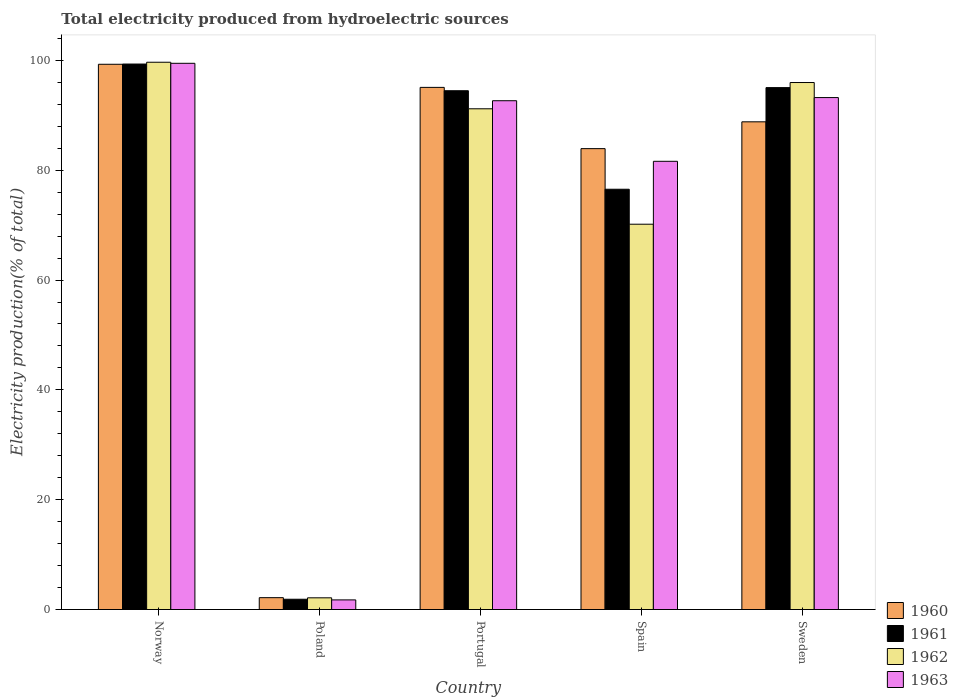How many groups of bars are there?
Give a very brief answer. 5. How many bars are there on the 2nd tick from the right?
Offer a terse response. 4. In how many cases, is the number of bars for a given country not equal to the number of legend labels?
Ensure brevity in your answer.  0. What is the total electricity produced in 1961 in Sweden?
Offer a very short reply. 95.05. Across all countries, what is the maximum total electricity produced in 1963?
Provide a succinct answer. 99.47. Across all countries, what is the minimum total electricity produced in 1961?
Offer a terse response. 1.87. In which country was the total electricity produced in 1961 maximum?
Give a very brief answer. Norway. In which country was the total electricity produced in 1963 minimum?
Your answer should be compact. Poland. What is the total total electricity produced in 1960 in the graph?
Offer a terse response. 369.31. What is the difference between the total electricity produced in 1960 in Norway and that in Poland?
Provide a short and direct response. 97.14. What is the difference between the total electricity produced in 1963 in Portugal and the total electricity produced in 1961 in Spain?
Give a very brief answer. 16.12. What is the average total electricity produced in 1961 per country?
Provide a succinct answer. 73.46. What is the difference between the total electricity produced of/in 1962 and total electricity produced of/in 1961 in Poland?
Offer a terse response. 0.26. In how many countries, is the total electricity produced in 1960 greater than 28 %?
Offer a very short reply. 4. What is the ratio of the total electricity produced in 1963 in Norway to that in Spain?
Offer a very short reply. 1.22. Is the total electricity produced in 1960 in Norway less than that in Spain?
Your answer should be very brief. No. What is the difference between the highest and the second highest total electricity produced in 1960?
Ensure brevity in your answer.  -10.48. What is the difference between the highest and the lowest total electricity produced in 1961?
Your response must be concise. 97.47. Is it the case that in every country, the sum of the total electricity produced in 1962 and total electricity produced in 1961 is greater than the sum of total electricity produced in 1960 and total electricity produced in 1963?
Your response must be concise. No. What does the 2nd bar from the left in Poland represents?
Offer a terse response. 1961. Are all the bars in the graph horizontal?
Your answer should be very brief. No. How many countries are there in the graph?
Ensure brevity in your answer.  5. Are the values on the major ticks of Y-axis written in scientific E-notation?
Your answer should be compact. No. Does the graph contain any zero values?
Your answer should be compact. No. What is the title of the graph?
Your answer should be compact. Total electricity produced from hydroelectric sources. What is the Electricity production(% of total) of 1960 in Norway?
Your response must be concise. 99.3. What is the Electricity production(% of total) in 1961 in Norway?
Offer a very short reply. 99.34. What is the Electricity production(% of total) in 1962 in Norway?
Ensure brevity in your answer.  99.67. What is the Electricity production(% of total) of 1963 in Norway?
Your answer should be very brief. 99.47. What is the Electricity production(% of total) of 1960 in Poland?
Keep it short and to the point. 2.16. What is the Electricity production(% of total) in 1961 in Poland?
Provide a succinct answer. 1.87. What is the Electricity production(% of total) of 1962 in Poland?
Your response must be concise. 2.13. What is the Electricity production(% of total) in 1963 in Poland?
Ensure brevity in your answer.  1.75. What is the Electricity production(% of total) of 1960 in Portugal?
Give a very brief answer. 95.09. What is the Electricity production(% of total) in 1961 in Portugal?
Keep it short and to the point. 94.48. What is the Electricity production(% of total) of 1962 in Portugal?
Provide a short and direct response. 91.19. What is the Electricity production(% of total) in 1963 in Portugal?
Provide a succinct answer. 92.66. What is the Electricity production(% of total) in 1960 in Spain?
Provide a short and direct response. 83.94. What is the Electricity production(% of total) in 1961 in Spain?
Give a very brief answer. 76.54. What is the Electricity production(% of total) of 1962 in Spain?
Offer a terse response. 70.17. What is the Electricity production(% of total) in 1963 in Spain?
Offer a very short reply. 81.63. What is the Electricity production(% of total) of 1960 in Sweden?
Provide a succinct answer. 88.82. What is the Electricity production(% of total) in 1961 in Sweden?
Provide a short and direct response. 95.05. What is the Electricity production(% of total) of 1962 in Sweden?
Offer a terse response. 95.98. What is the Electricity production(% of total) of 1963 in Sweden?
Make the answer very short. 93.24. Across all countries, what is the maximum Electricity production(% of total) of 1960?
Give a very brief answer. 99.3. Across all countries, what is the maximum Electricity production(% of total) of 1961?
Give a very brief answer. 99.34. Across all countries, what is the maximum Electricity production(% of total) of 1962?
Make the answer very short. 99.67. Across all countries, what is the maximum Electricity production(% of total) in 1963?
Offer a very short reply. 99.47. Across all countries, what is the minimum Electricity production(% of total) in 1960?
Provide a succinct answer. 2.16. Across all countries, what is the minimum Electricity production(% of total) of 1961?
Provide a short and direct response. 1.87. Across all countries, what is the minimum Electricity production(% of total) in 1962?
Keep it short and to the point. 2.13. Across all countries, what is the minimum Electricity production(% of total) of 1963?
Your response must be concise. 1.75. What is the total Electricity production(% of total) in 1960 in the graph?
Keep it short and to the point. 369.31. What is the total Electricity production(% of total) of 1961 in the graph?
Provide a short and direct response. 367.29. What is the total Electricity production(% of total) in 1962 in the graph?
Give a very brief answer. 359.14. What is the total Electricity production(% of total) in 1963 in the graph?
Provide a short and direct response. 368.75. What is the difference between the Electricity production(% of total) of 1960 in Norway and that in Poland?
Ensure brevity in your answer.  97.14. What is the difference between the Electricity production(% of total) of 1961 in Norway and that in Poland?
Offer a very short reply. 97.47. What is the difference between the Electricity production(% of total) of 1962 in Norway and that in Poland?
Your answer should be compact. 97.54. What is the difference between the Electricity production(% of total) in 1963 in Norway and that in Poland?
Your answer should be compact. 97.72. What is the difference between the Electricity production(% of total) of 1960 in Norway and that in Portugal?
Provide a short and direct response. 4.21. What is the difference between the Electricity production(% of total) of 1961 in Norway and that in Portugal?
Offer a terse response. 4.86. What is the difference between the Electricity production(% of total) of 1962 in Norway and that in Portugal?
Your response must be concise. 8.48. What is the difference between the Electricity production(% of total) in 1963 in Norway and that in Portugal?
Your response must be concise. 6.81. What is the difference between the Electricity production(% of total) of 1960 in Norway and that in Spain?
Your answer should be very brief. 15.36. What is the difference between the Electricity production(% of total) of 1961 in Norway and that in Spain?
Provide a succinct answer. 22.8. What is the difference between the Electricity production(% of total) of 1962 in Norway and that in Spain?
Give a very brief answer. 29.5. What is the difference between the Electricity production(% of total) in 1963 in Norway and that in Spain?
Keep it short and to the point. 17.85. What is the difference between the Electricity production(% of total) of 1960 in Norway and that in Sweden?
Offer a very short reply. 10.48. What is the difference between the Electricity production(% of total) of 1961 in Norway and that in Sweden?
Your response must be concise. 4.29. What is the difference between the Electricity production(% of total) of 1962 in Norway and that in Sweden?
Your answer should be compact. 3.69. What is the difference between the Electricity production(% of total) in 1963 in Norway and that in Sweden?
Your response must be concise. 6.24. What is the difference between the Electricity production(% of total) in 1960 in Poland and that in Portugal?
Your answer should be compact. -92.93. What is the difference between the Electricity production(% of total) of 1961 in Poland and that in Portugal?
Provide a succinct answer. -92.61. What is the difference between the Electricity production(% of total) of 1962 in Poland and that in Portugal?
Ensure brevity in your answer.  -89.06. What is the difference between the Electricity production(% of total) in 1963 in Poland and that in Portugal?
Your response must be concise. -90.91. What is the difference between the Electricity production(% of total) of 1960 in Poland and that in Spain?
Provide a short and direct response. -81.78. What is the difference between the Electricity production(% of total) in 1961 in Poland and that in Spain?
Keep it short and to the point. -74.67. What is the difference between the Electricity production(% of total) of 1962 in Poland and that in Spain?
Your answer should be compact. -68.04. What is the difference between the Electricity production(% of total) in 1963 in Poland and that in Spain?
Keep it short and to the point. -79.88. What is the difference between the Electricity production(% of total) in 1960 in Poland and that in Sweden?
Offer a very short reply. -86.66. What is the difference between the Electricity production(% of total) of 1961 in Poland and that in Sweden?
Provide a short and direct response. -93.17. What is the difference between the Electricity production(% of total) in 1962 in Poland and that in Sweden?
Your answer should be compact. -93.84. What is the difference between the Electricity production(% of total) of 1963 in Poland and that in Sweden?
Provide a succinct answer. -91.48. What is the difference between the Electricity production(% of total) of 1960 in Portugal and that in Spain?
Offer a terse response. 11.15. What is the difference between the Electricity production(% of total) in 1961 in Portugal and that in Spain?
Your answer should be compact. 17.94. What is the difference between the Electricity production(% of total) in 1962 in Portugal and that in Spain?
Your response must be concise. 21.02. What is the difference between the Electricity production(% of total) in 1963 in Portugal and that in Spain?
Your answer should be very brief. 11.03. What is the difference between the Electricity production(% of total) of 1960 in Portugal and that in Sweden?
Make the answer very short. 6.27. What is the difference between the Electricity production(% of total) in 1961 in Portugal and that in Sweden?
Ensure brevity in your answer.  -0.57. What is the difference between the Electricity production(% of total) in 1962 in Portugal and that in Sweden?
Provide a short and direct response. -4.78. What is the difference between the Electricity production(% of total) in 1963 in Portugal and that in Sweden?
Your answer should be very brief. -0.58. What is the difference between the Electricity production(% of total) of 1960 in Spain and that in Sweden?
Your answer should be compact. -4.88. What is the difference between the Electricity production(% of total) in 1961 in Spain and that in Sweden?
Ensure brevity in your answer.  -18.51. What is the difference between the Electricity production(% of total) of 1962 in Spain and that in Sweden?
Provide a short and direct response. -25.8. What is the difference between the Electricity production(% of total) of 1963 in Spain and that in Sweden?
Give a very brief answer. -11.61. What is the difference between the Electricity production(% of total) in 1960 in Norway and the Electricity production(% of total) in 1961 in Poland?
Keep it short and to the point. 97.43. What is the difference between the Electricity production(% of total) of 1960 in Norway and the Electricity production(% of total) of 1962 in Poland?
Your answer should be compact. 97.17. What is the difference between the Electricity production(% of total) of 1960 in Norway and the Electricity production(% of total) of 1963 in Poland?
Your response must be concise. 97.55. What is the difference between the Electricity production(% of total) of 1961 in Norway and the Electricity production(% of total) of 1962 in Poland?
Provide a succinct answer. 97.21. What is the difference between the Electricity production(% of total) of 1961 in Norway and the Electricity production(% of total) of 1963 in Poland?
Ensure brevity in your answer.  97.59. What is the difference between the Electricity production(% of total) of 1962 in Norway and the Electricity production(% of total) of 1963 in Poland?
Ensure brevity in your answer.  97.92. What is the difference between the Electricity production(% of total) in 1960 in Norway and the Electricity production(% of total) in 1961 in Portugal?
Give a very brief answer. 4.82. What is the difference between the Electricity production(% of total) of 1960 in Norway and the Electricity production(% of total) of 1962 in Portugal?
Your response must be concise. 8.11. What is the difference between the Electricity production(% of total) of 1960 in Norway and the Electricity production(% of total) of 1963 in Portugal?
Your answer should be very brief. 6.64. What is the difference between the Electricity production(% of total) of 1961 in Norway and the Electricity production(% of total) of 1962 in Portugal?
Keep it short and to the point. 8.15. What is the difference between the Electricity production(% of total) in 1961 in Norway and the Electricity production(% of total) in 1963 in Portugal?
Keep it short and to the point. 6.68. What is the difference between the Electricity production(% of total) of 1962 in Norway and the Electricity production(% of total) of 1963 in Portugal?
Keep it short and to the point. 7.01. What is the difference between the Electricity production(% of total) in 1960 in Norway and the Electricity production(% of total) in 1961 in Spain?
Your response must be concise. 22.76. What is the difference between the Electricity production(% of total) of 1960 in Norway and the Electricity production(% of total) of 1962 in Spain?
Give a very brief answer. 29.13. What is the difference between the Electricity production(% of total) of 1960 in Norway and the Electricity production(% of total) of 1963 in Spain?
Offer a very short reply. 17.67. What is the difference between the Electricity production(% of total) of 1961 in Norway and the Electricity production(% of total) of 1962 in Spain?
Keep it short and to the point. 29.17. What is the difference between the Electricity production(% of total) in 1961 in Norway and the Electricity production(% of total) in 1963 in Spain?
Your answer should be very brief. 17.72. What is the difference between the Electricity production(% of total) of 1962 in Norway and the Electricity production(% of total) of 1963 in Spain?
Your answer should be compact. 18.04. What is the difference between the Electricity production(% of total) in 1960 in Norway and the Electricity production(% of total) in 1961 in Sweden?
Your response must be concise. 4.25. What is the difference between the Electricity production(% of total) in 1960 in Norway and the Electricity production(% of total) in 1962 in Sweden?
Offer a very short reply. 3.33. What is the difference between the Electricity production(% of total) of 1960 in Norway and the Electricity production(% of total) of 1963 in Sweden?
Ensure brevity in your answer.  6.06. What is the difference between the Electricity production(% of total) of 1961 in Norway and the Electricity production(% of total) of 1962 in Sweden?
Keep it short and to the point. 3.37. What is the difference between the Electricity production(% of total) in 1961 in Norway and the Electricity production(% of total) in 1963 in Sweden?
Ensure brevity in your answer.  6.11. What is the difference between the Electricity production(% of total) in 1962 in Norway and the Electricity production(% of total) in 1963 in Sweden?
Offer a terse response. 6.43. What is the difference between the Electricity production(% of total) of 1960 in Poland and the Electricity production(% of total) of 1961 in Portugal?
Your answer should be very brief. -92.32. What is the difference between the Electricity production(% of total) in 1960 in Poland and the Electricity production(% of total) in 1962 in Portugal?
Provide a succinct answer. -89.03. What is the difference between the Electricity production(% of total) in 1960 in Poland and the Electricity production(% of total) in 1963 in Portugal?
Keep it short and to the point. -90.5. What is the difference between the Electricity production(% of total) in 1961 in Poland and the Electricity production(% of total) in 1962 in Portugal?
Offer a terse response. -89.32. What is the difference between the Electricity production(% of total) of 1961 in Poland and the Electricity production(% of total) of 1963 in Portugal?
Your response must be concise. -90.79. What is the difference between the Electricity production(% of total) in 1962 in Poland and the Electricity production(% of total) in 1963 in Portugal?
Keep it short and to the point. -90.53. What is the difference between the Electricity production(% of total) of 1960 in Poland and the Electricity production(% of total) of 1961 in Spain?
Keep it short and to the point. -74.38. What is the difference between the Electricity production(% of total) in 1960 in Poland and the Electricity production(% of total) in 1962 in Spain?
Your answer should be compact. -68.01. What is the difference between the Electricity production(% of total) of 1960 in Poland and the Electricity production(% of total) of 1963 in Spain?
Make the answer very short. -79.47. What is the difference between the Electricity production(% of total) in 1961 in Poland and the Electricity production(% of total) in 1962 in Spain?
Provide a short and direct response. -68.3. What is the difference between the Electricity production(% of total) in 1961 in Poland and the Electricity production(% of total) in 1963 in Spain?
Your answer should be very brief. -79.75. What is the difference between the Electricity production(% of total) in 1962 in Poland and the Electricity production(% of total) in 1963 in Spain?
Make the answer very short. -79.5. What is the difference between the Electricity production(% of total) of 1960 in Poland and the Electricity production(% of total) of 1961 in Sweden?
Your answer should be compact. -92.89. What is the difference between the Electricity production(% of total) of 1960 in Poland and the Electricity production(% of total) of 1962 in Sweden?
Provide a short and direct response. -93.82. What is the difference between the Electricity production(% of total) in 1960 in Poland and the Electricity production(% of total) in 1963 in Sweden?
Make the answer very short. -91.08. What is the difference between the Electricity production(% of total) in 1961 in Poland and the Electricity production(% of total) in 1962 in Sweden?
Give a very brief answer. -94.1. What is the difference between the Electricity production(% of total) of 1961 in Poland and the Electricity production(% of total) of 1963 in Sweden?
Your answer should be compact. -91.36. What is the difference between the Electricity production(% of total) of 1962 in Poland and the Electricity production(% of total) of 1963 in Sweden?
Offer a terse response. -91.1. What is the difference between the Electricity production(% of total) in 1960 in Portugal and the Electricity production(% of total) in 1961 in Spain?
Give a very brief answer. 18.55. What is the difference between the Electricity production(% of total) of 1960 in Portugal and the Electricity production(% of total) of 1962 in Spain?
Provide a short and direct response. 24.92. What is the difference between the Electricity production(% of total) in 1960 in Portugal and the Electricity production(% of total) in 1963 in Spain?
Keep it short and to the point. 13.46. What is the difference between the Electricity production(% of total) of 1961 in Portugal and the Electricity production(% of total) of 1962 in Spain?
Provide a short and direct response. 24.31. What is the difference between the Electricity production(% of total) in 1961 in Portugal and the Electricity production(% of total) in 1963 in Spain?
Offer a very short reply. 12.85. What is the difference between the Electricity production(% of total) in 1962 in Portugal and the Electricity production(% of total) in 1963 in Spain?
Your answer should be compact. 9.57. What is the difference between the Electricity production(% of total) in 1960 in Portugal and the Electricity production(% of total) in 1961 in Sweden?
Your answer should be very brief. 0.04. What is the difference between the Electricity production(% of total) in 1960 in Portugal and the Electricity production(% of total) in 1962 in Sweden?
Provide a short and direct response. -0.89. What is the difference between the Electricity production(% of total) in 1960 in Portugal and the Electricity production(% of total) in 1963 in Sweden?
Give a very brief answer. 1.85. What is the difference between the Electricity production(% of total) in 1961 in Portugal and the Electricity production(% of total) in 1962 in Sweden?
Give a very brief answer. -1.49. What is the difference between the Electricity production(% of total) in 1961 in Portugal and the Electricity production(% of total) in 1963 in Sweden?
Provide a short and direct response. 1.24. What is the difference between the Electricity production(% of total) in 1962 in Portugal and the Electricity production(% of total) in 1963 in Sweden?
Ensure brevity in your answer.  -2.04. What is the difference between the Electricity production(% of total) in 1960 in Spain and the Electricity production(% of total) in 1961 in Sweden?
Your response must be concise. -11.11. What is the difference between the Electricity production(% of total) of 1960 in Spain and the Electricity production(% of total) of 1962 in Sweden?
Provide a succinct answer. -12.04. What is the difference between the Electricity production(% of total) in 1960 in Spain and the Electricity production(% of total) in 1963 in Sweden?
Your response must be concise. -9.3. What is the difference between the Electricity production(% of total) of 1961 in Spain and the Electricity production(% of total) of 1962 in Sweden?
Your response must be concise. -19.44. What is the difference between the Electricity production(% of total) of 1961 in Spain and the Electricity production(% of total) of 1963 in Sweden?
Ensure brevity in your answer.  -16.7. What is the difference between the Electricity production(% of total) in 1962 in Spain and the Electricity production(% of total) in 1963 in Sweden?
Provide a short and direct response. -23.06. What is the average Electricity production(% of total) in 1960 per country?
Offer a very short reply. 73.86. What is the average Electricity production(% of total) in 1961 per country?
Offer a terse response. 73.46. What is the average Electricity production(% of total) in 1962 per country?
Provide a succinct answer. 71.83. What is the average Electricity production(% of total) in 1963 per country?
Provide a succinct answer. 73.75. What is the difference between the Electricity production(% of total) in 1960 and Electricity production(% of total) in 1961 in Norway?
Your response must be concise. -0.04. What is the difference between the Electricity production(% of total) of 1960 and Electricity production(% of total) of 1962 in Norway?
Your response must be concise. -0.37. What is the difference between the Electricity production(% of total) in 1960 and Electricity production(% of total) in 1963 in Norway?
Your response must be concise. -0.17. What is the difference between the Electricity production(% of total) of 1961 and Electricity production(% of total) of 1962 in Norway?
Your response must be concise. -0.33. What is the difference between the Electricity production(% of total) in 1961 and Electricity production(% of total) in 1963 in Norway?
Ensure brevity in your answer.  -0.13. What is the difference between the Electricity production(% of total) in 1962 and Electricity production(% of total) in 1963 in Norway?
Your response must be concise. 0.19. What is the difference between the Electricity production(% of total) in 1960 and Electricity production(% of total) in 1961 in Poland?
Make the answer very short. 0.28. What is the difference between the Electricity production(% of total) of 1960 and Electricity production(% of total) of 1962 in Poland?
Give a very brief answer. 0.03. What is the difference between the Electricity production(% of total) of 1960 and Electricity production(% of total) of 1963 in Poland?
Provide a succinct answer. 0.41. What is the difference between the Electricity production(% of total) of 1961 and Electricity production(% of total) of 1962 in Poland?
Provide a short and direct response. -0.26. What is the difference between the Electricity production(% of total) in 1961 and Electricity production(% of total) in 1963 in Poland?
Offer a terse response. 0.12. What is the difference between the Electricity production(% of total) in 1962 and Electricity production(% of total) in 1963 in Poland?
Provide a succinct answer. 0.38. What is the difference between the Electricity production(% of total) in 1960 and Electricity production(% of total) in 1961 in Portugal?
Keep it short and to the point. 0.61. What is the difference between the Electricity production(% of total) of 1960 and Electricity production(% of total) of 1962 in Portugal?
Your answer should be compact. 3.9. What is the difference between the Electricity production(% of total) of 1960 and Electricity production(% of total) of 1963 in Portugal?
Make the answer very short. 2.43. What is the difference between the Electricity production(% of total) in 1961 and Electricity production(% of total) in 1962 in Portugal?
Your answer should be very brief. 3.29. What is the difference between the Electricity production(% of total) in 1961 and Electricity production(% of total) in 1963 in Portugal?
Ensure brevity in your answer.  1.82. What is the difference between the Electricity production(% of total) in 1962 and Electricity production(% of total) in 1963 in Portugal?
Provide a succinct answer. -1.47. What is the difference between the Electricity production(% of total) of 1960 and Electricity production(% of total) of 1961 in Spain?
Give a very brief answer. 7.4. What is the difference between the Electricity production(% of total) of 1960 and Electricity production(% of total) of 1962 in Spain?
Offer a terse response. 13.76. What is the difference between the Electricity production(% of total) in 1960 and Electricity production(% of total) in 1963 in Spain?
Give a very brief answer. 2.31. What is the difference between the Electricity production(% of total) of 1961 and Electricity production(% of total) of 1962 in Spain?
Your response must be concise. 6.37. What is the difference between the Electricity production(% of total) in 1961 and Electricity production(% of total) in 1963 in Spain?
Your answer should be compact. -5.09. What is the difference between the Electricity production(% of total) in 1962 and Electricity production(% of total) in 1963 in Spain?
Offer a very short reply. -11.45. What is the difference between the Electricity production(% of total) in 1960 and Electricity production(% of total) in 1961 in Sweden?
Make the answer very short. -6.23. What is the difference between the Electricity production(% of total) of 1960 and Electricity production(% of total) of 1962 in Sweden?
Offer a terse response. -7.16. What is the difference between the Electricity production(% of total) in 1960 and Electricity production(% of total) in 1963 in Sweden?
Provide a succinct answer. -4.42. What is the difference between the Electricity production(% of total) in 1961 and Electricity production(% of total) in 1962 in Sweden?
Offer a very short reply. -0.93. What is the difference between the Electricity production(% of total) in 1961 and Electricity production(% of total) in 1963 in Sweden?
Keep it short and to the point. 1.81. What is the difference between the Electricity production(% of total) of 1962 and Electricity production(% of total) of 1963 in Sweden?
Your answer should be very brief. 2.74. What is the ratio of the Electricity production(% of total) in 1960 in Norway to that in Poland?
Keep it short and to the point. 46.01. What is the ratio of the Electricity production(% of total) in 1961 in Norway to that in Poland?
Your answer should be compact. 53.03. What is the ratio of the Electricity production(% of total) in 1962 in Norway to that in Poland?
Your answer should be very brief. 46.75. What is the ratio of the Electricity production(% of total) in 1963 in Norway to that in Poland?
Keep it short and to the point. 56.8. What is the ratio of the Electricity production(% of total) in 1960 in Norway to that in Portugal?
Offer a terse response. 1.04. What is the ratio of the Electricity production(% of total) in 1961 in Norway to that in Portugal?
Your response must be concise. 1.05. What is the ratio of the Electricity production(% of total) of 1962 in Norway to that in Portugal?
Provide a succinct answer. 1.09. What is the ratio of the Electricity production(% of total) in 1963 in Norway to that in Portugal?
Give a very brief answer. 1.07. What is the ratio of the Electricity production(% of total) of 1960 in Norway to that in Spain?
Ensure brevity in your answer.  1.18. What is the ratio of the Electricity production(% of total) of 1961 in Norway to that in Spain?
Ensure brevity in your answer.  1.3. What is the ratio of the Electricity production(% of total) of 1962 in Norway to that in Spain?
Give a very brief answer. 1.42. What is the ratio of the Electricity production(% of total) in 1963 in Norway to that in Spain?
Ensure brevity in your answer.  1.22. What is the ratio of the Electricity production(% of total) in 1960 in Norway to that in Sweden?
Your answer should be very brief. 1.12. What is the ratio of the Electricity production(% of total) in 1961 in Norway to that in Sweden?
Your response must be concise. 1.05. What is the ratio of the Electricity production(% of total) of 1962 in Norway to that in Sweden?
Give a very brief answer. 1.04. What is the ratio of the Electricity production(% of total) of 1963 in Norway to that in Sweden?
Make the answer very short. 1.07. What is the ratio of the Electricity production(% of total) of 1960 in Poland to that in Portugal?
Keep it short and to the point. 0.02. What is the ratio of the Electricity production(% of total) of 1961 in Poland to that in Portugal?
Ensure brevity in your answer.  0.02. What is the ratio of the Electricity production(% of total) in 1962 in Poland to that in Portugal?
Your answer should be compact. 0.02. What is the ratio of the Electricity production(% of total) of 1963 in Poland to that in Portugal?
Your answer should be very brief. 0.02. What is the ratio of the Electricity production(% of total) of 1960 in Poland to that in Spain?
Give a very brief answer. 0.03. What is the ratio of the Electricity production(% of total) of 1961 in Poland to that in Spain?
Your answer should be compact. 0.02. What is the ratio of the Electricity production(% of total) of 1962 in Poland to that in Spain?
Keep it short and to the point. 0.03. What is the ratio of the Electricity production(% of total) in 1963 in Poland to that in Spain?
Your answer should be very brief. 0.02. What is the ratio of the Electricity production(% of total) of 1960 in Poland to that in Sweden?
Your answer should be very brief. 0.02. What is the ratio of the Electricity production(% of total) of 1961 in Poland to that in Sweden?
Ensure brevity in your answer.  0.02. What is the ratio of the Electricity production(% of total) in 1962 in Poland to that in Sweden?
Offer a terse response. 0.02. What is the ratio of the Electricity production(% of total) in 1963 in Poland to that in Sweden?
Ensure brevity in your answer.  0.02. What is the ratio of the Electricity production(% of total) of 1960 in Portugal to that in Spain?
Your response must be concise. 1.13. What is the ratio of the Electricity production(% of total) in 1961 in Portugal to that in Spain?
Make the answer very short. 1.23. What is the ratio of the Electricity production(% of total) in 1962 in Portugal to that in Spain?
Make the answer very short. 1.3. What is the ratio of the Electricity production(% of total) in 1963 in Portugal to that in Spain?
Ensure brevity in your answer.  1.14. What is the ratio of the Electricity production(% of total) in 1960 in Portugal to that in Sweden?
Ensure brevity in your answer.  1.07. What is the ratio of the Electricity production(% of total) of 1961 in Portugal to that in Sweden?
Your answer should be compact. 0.99. What is the ratio of the Electricity production(% of total) in 1962 in Portugal to that in Sweden?
Provide a short and direct response. 0.95. What is the ratio of the Electricity production(% of total) in 1963 in Portugal to that in Sweden?
Your answer should be compact. 0.99. What is the ratio of the Electricity production(% of total) in 1960 in Spain to that in Sweden?
Ensure brevity in your answer.  0.94. What is the ratio of the Electricity production(% of total) in 1961 in Spain to that in Sweden?
Your answer should be compact. 0.81. What is the ratio of the Electricity production(% of total) of 1962 in Spain to that in Sweden?
Your answer should be compact. 0.73. What is the ratio of the Electricity production(% of total) of 1963 in Spain to that in Sweden?
Make the answer very short. 0.88. What is the difference between the highest and the second highest Electricity production(% of total) in 1960?
Your response must be concise. 4.21. What is the difference between the highest and the second highest Electricity production(% of total) in 1961?
Offer a terse response. 4.29. What is the difference between the highest and the second highest Electricity production(% of total) of 1962?
Offer a very short reply. 3.69. What is the difference between the highest and the second highest Electricity production(% of total) of 1963?
Keep it short and to the point. 6.24. What is the difference between the highest and the lowest Electricity production(% of total) of 1960?
Keep it short and to the point. 97.14. What is the difference between the highest and the lowest Electricity production(% of total) of 1961?
Your answer should be compact. 97.47. What is the difference between the highest and the lowest Electricity production(% of total) of 1962?
Offer a very short reply. 97.54. What is the difference between the highest and the lowest Electricity production(% of total) in 1963?
Offer a terse response. 97.72. 